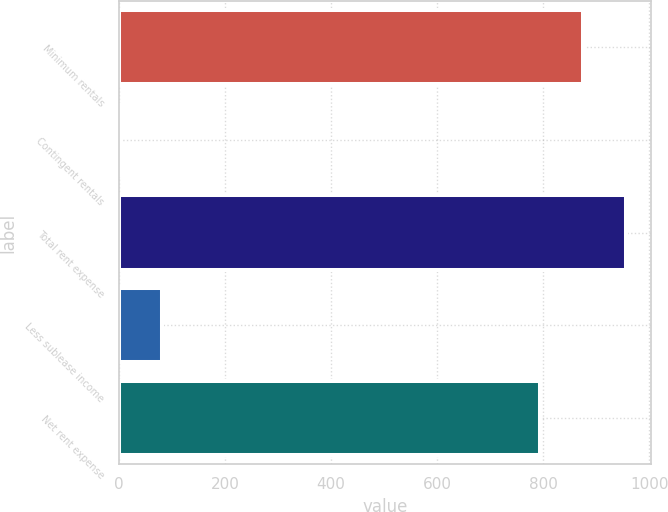Convert chart. <chart><loc_0><loc_0><loc_500><loc_500><bar_chart><fcel>Minimum rentals<fcel>Contingent rentals<fcel>Total rent expense<fcel>Less sublease income<fcel>Net rent expense<nl><fcel>874.9<fcel>1<fcel>955.8<fcel>81.9<fcel>794<nl></chart> 